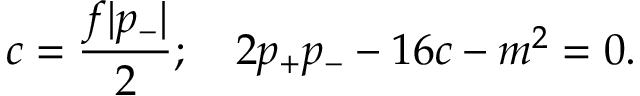Convert formula to latex. <formula><loc_0><loc_0><loc_500><loc_500>c = { \frac { f | p _ { - } | } { 2 } } ; \quad 2 p _ { + } p _ { - } - 1 6 c - m ^ { 2 } = 0 .</formula> 